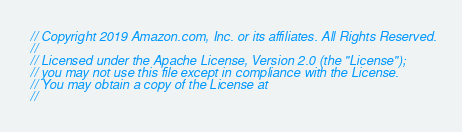Convert code to text. <code><loc_0><loc_0><loc_500><loc_500><_C++_>// Copyright 2019 Amazon.com, Inc. or its affiliates. All Rights Reserved.
//
// Licensed under the Apache License, Version 2.0 (the "License");
// you may not use this file except in compliance with the License.
// You may obtain a copy of the License at
//</code> 